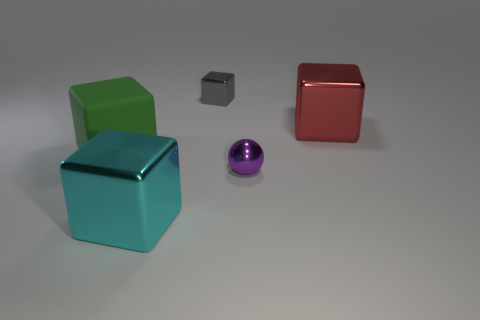Are there any other things that are made of the same material as the green thing?
Give a very brief answer. No. Is the large thing left of the cyan block made of the same material as the cube in front of the small purple metallic thing?
Offer a terse response. No. What is the size of the shiny thing that is behind the big cyan cube and in front of the red metallic object?
Offer a very short reply. Small. There is another cyan thing that is the same size as the rubber thing; what is its material?
Ensure brevity in your answer.  Metal. There is a big block that is on the left side of the metallic cube in front of the matte object; what number of green cubes are in front of it?
Give a very brief answer. 0. There is a big object that is behind the purple metal thing and to the right of the big matte block; what color is it?
Ensure brevity in your answer.  Red. What number of green objects are the same size as the cyan object?
Offer a terse response. 1. What shape is the large thing right of the small thing that is in front of the tiny gray metal object?
Ensure brevity in your answer.  Cube. There is a large object right of the tiny thing in front of the tiny thing behind the large green block; what is its shape?
Ensure brevity in your answer.  Cube. How many red shiny things are the same shape as the gray metal thing?
Provide a short and direct response. 1. 